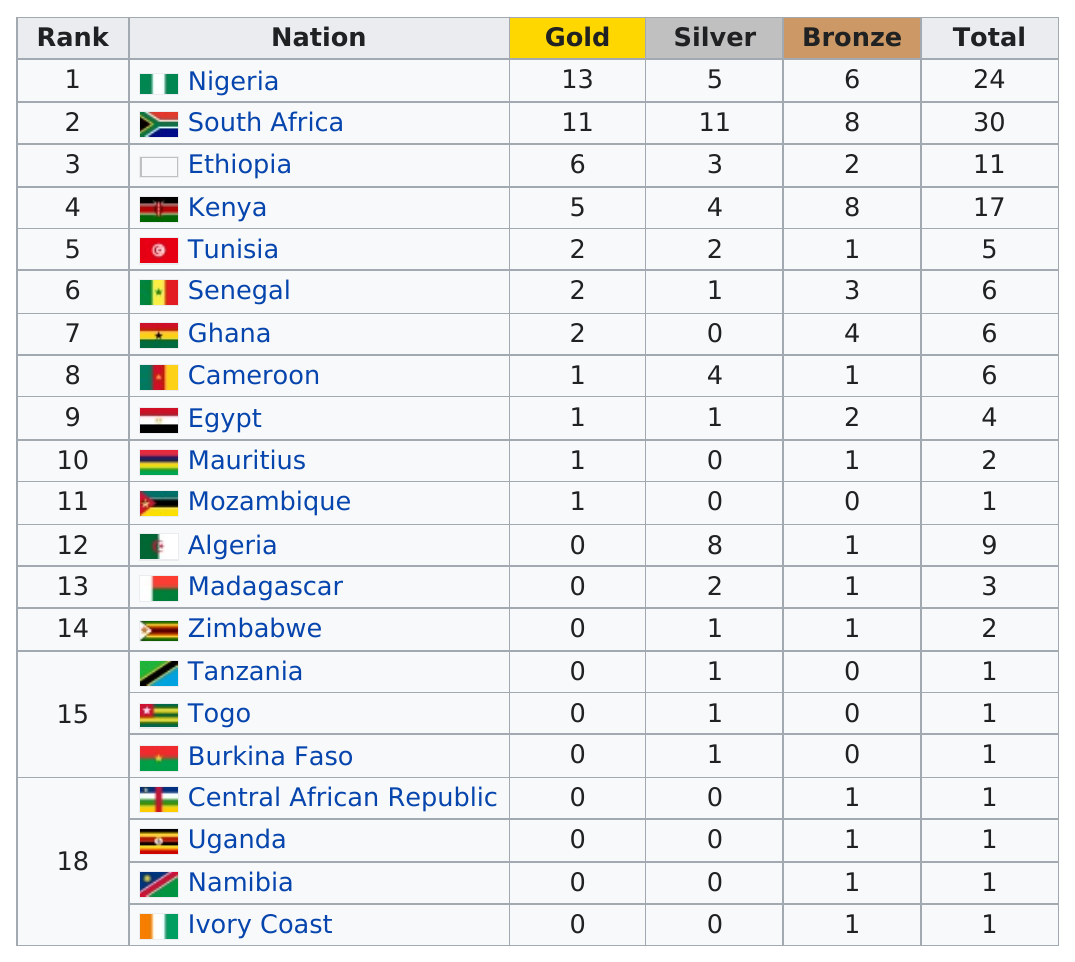Outline some significant characteristics in this image. The Central African Republic and Uganda each won one bronze medal. Four countries, Central African Republic, Uganda, Namibia, and Ivory Coast, were ranked last in the recent competition, each receiving only one bronze medal. Nigeria has the most gold medals, but South Africa has the most overall medals. Which nation has won more gold medals than South Africa? The answer is Nigeria. Algeria, an African country, won eight silver medals but did not win any gold medals. 